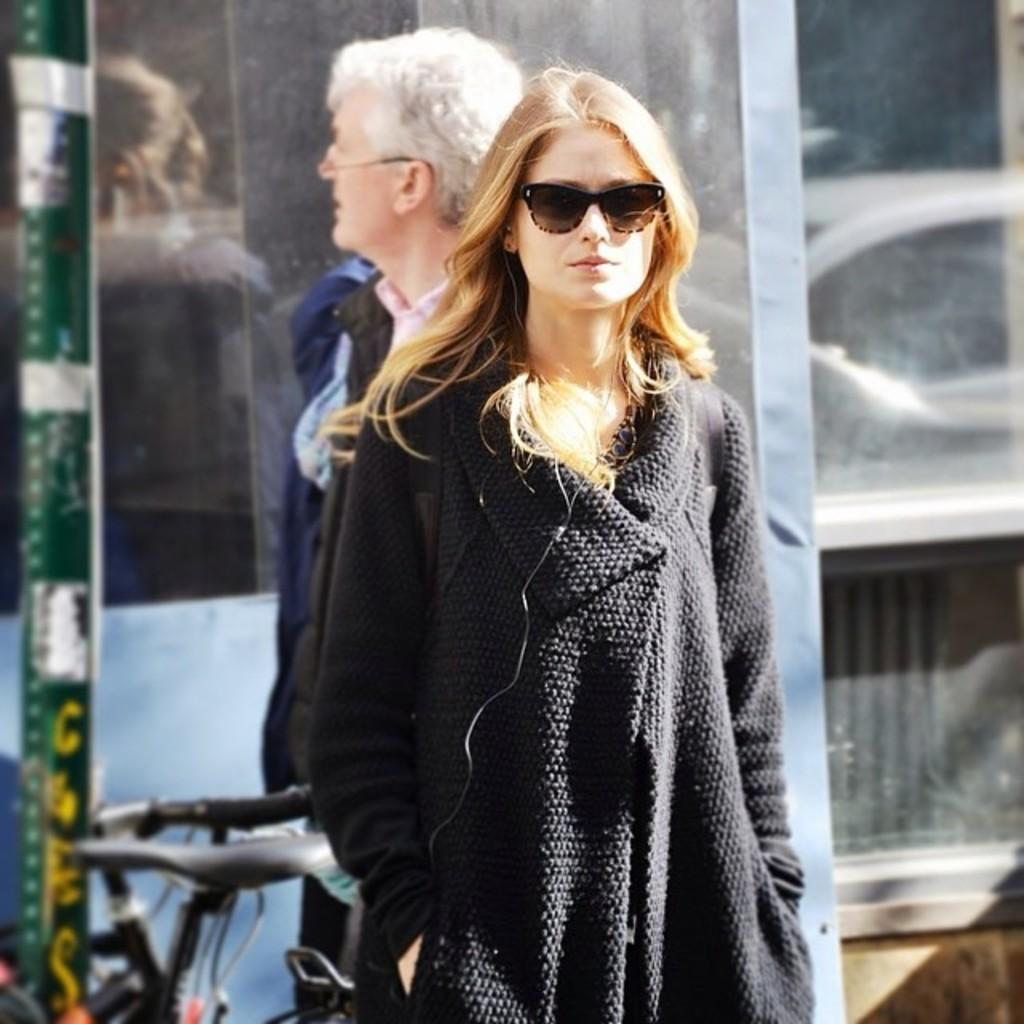Who is present in the image? There is a lady visible in the image. What is the lady wearing in the image? The lady is wearing spectacles in the image. Can you describe another object in the image? There is a bicycle in the image. What type of cast can be seen on the lady's leg in the image? There is no cast visible on the lady's leg in the image. Can you describe the mountain range in the background of the image? There is no mountain range present in the image. 